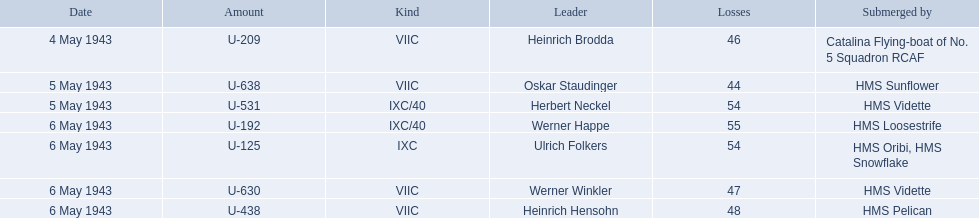Which were the names of the sinkers of the convoys? Catalina Flying-boat of No. 5 Squadron RCAF, HMS Sunflower, HMS Vidette, HMS Loosestrife, HMS Oribi, HMS Snowflake, HMS Vidette, HMS Pelican. What captain was sunk by the hms pelican? Heinrich Hensohn. 